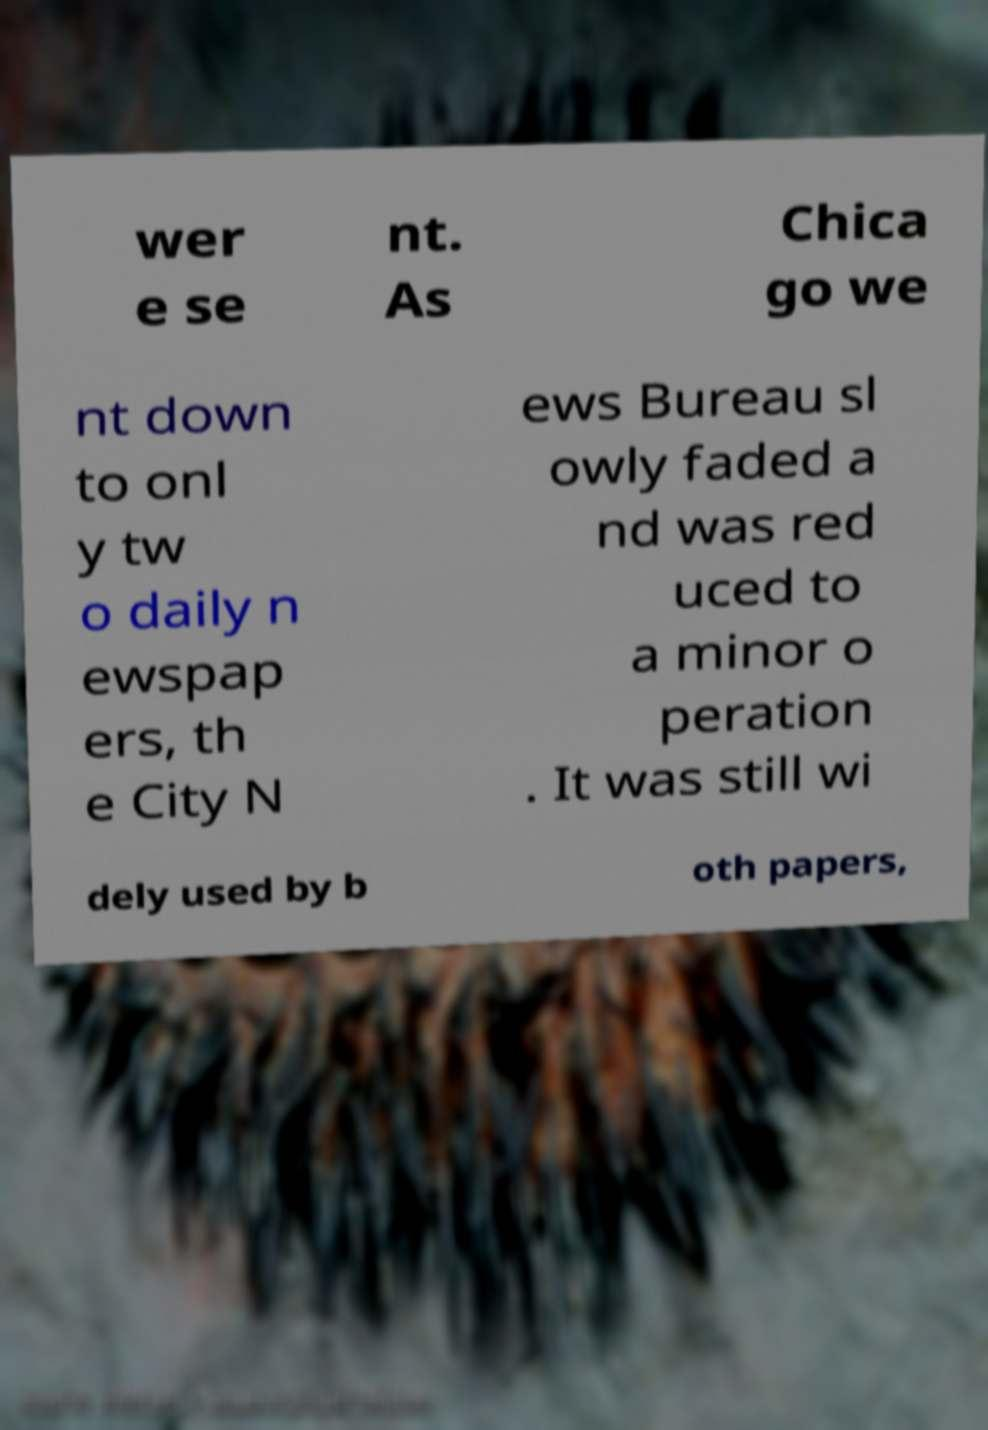Please read and relay the text visible in this image. What does it say? wer e se nt. As Chica go we nt down to onl y tw o daily n ewspap ers, th e City N ews Bureau sl owly faded a nd was red uced to a minor o peration . It was still wi dely used by b oth papers, 